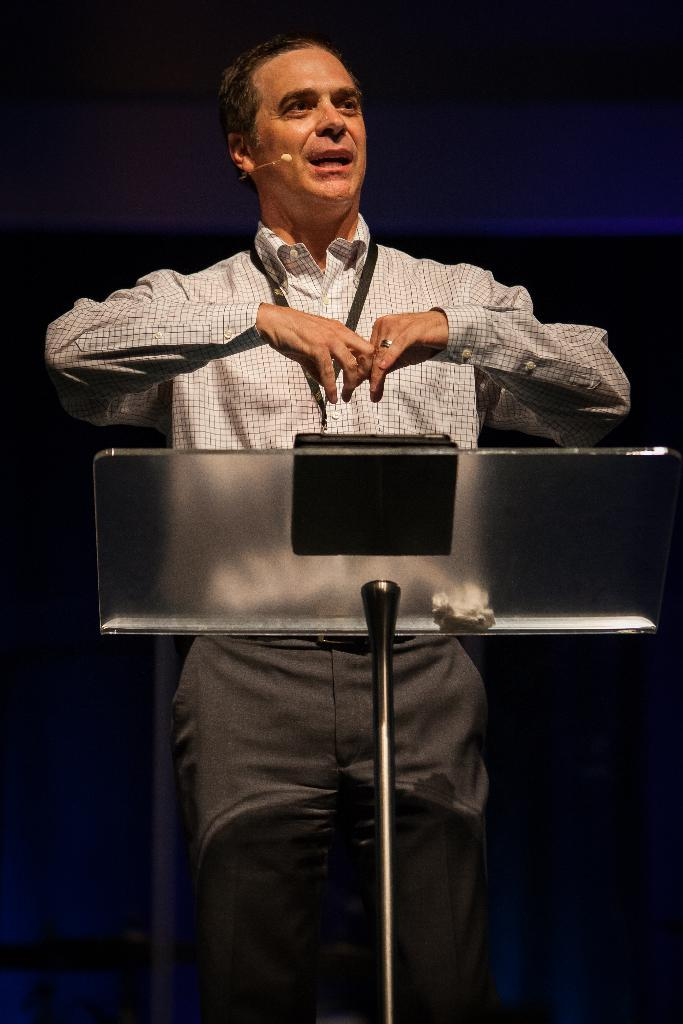Who is the main subject in the image? There is a man in the image. What is the man wearing in the image? The man is wearing a white, checkered shirt. Is there any identification visible on the man in the image? Yes, the man is wearing an ID card. What is the man standing behind in the image? The man is standing behind a glass podium. How would you describe the background of the image? The background of the image has a dark view. What type of cave can be seen in the background of the image? There is no cave present in the image; the background has a dark view, but it does not depict a cave. 